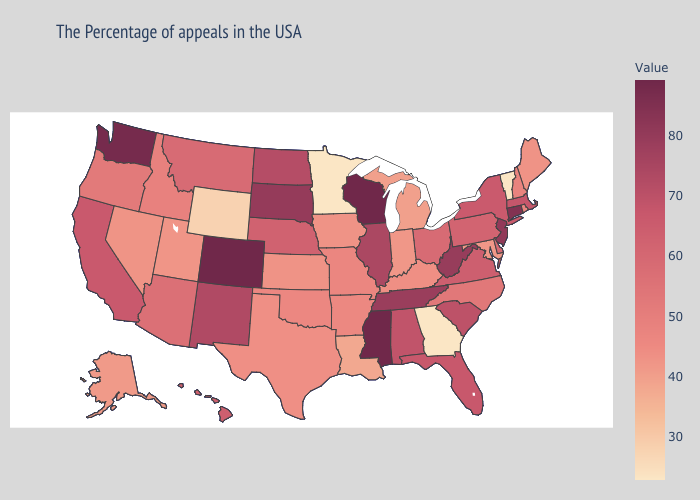Does Virginia have a lower value than Illinois?
Keep it brief. Yes. Does Nevada have a lower value than Wyoming?
Keep it brief. No. Which states have the highest value in the USA?
Give a very brief answer. Wisconsin, Mississippi, Colorado. Does Vermont have the lowest value in the USA?
Keep it brief. Yes. Which states have the highest value in the USA?
Answer briefly. Wisconsin, Mississippi, Colorado. Does Rhode Island have a lower value than California?
Quick response, please. Yes. Does South Carolina have a lower value than West Virginia?
Keep it brief. Yes. 